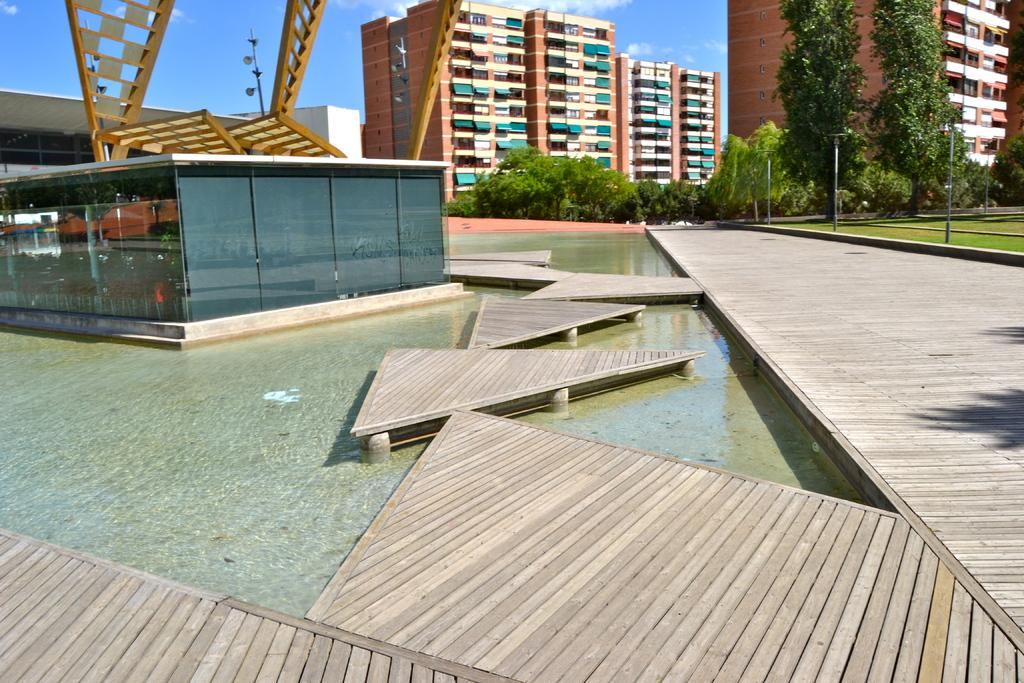What type of structures can be seen in the image? There are buildings in the image. What natural elements are present in the image? There are trees in the image. What are the poles used for in the image? The purpose of the poles is not specified, but they are visible in the image. What is the unique structure in the image? There is a glass house in the image. Can you describe the vegetation in the image? There is a tree in the image. What part of the natural environment is visible in the image? The sky is visible in the image. What type of pathways can be seen in the image? There are wooden-paths in the image. Can you see any fangs on the trees in the image? There are no fangs present on the trees in the image; they are regular trees. What type of oil is being extracted from the buildings in the image? There is no oil extraction taking place in the image, as it features buildings, trees, poles, a glass house, a tree, the sky, and wooden-paths. 